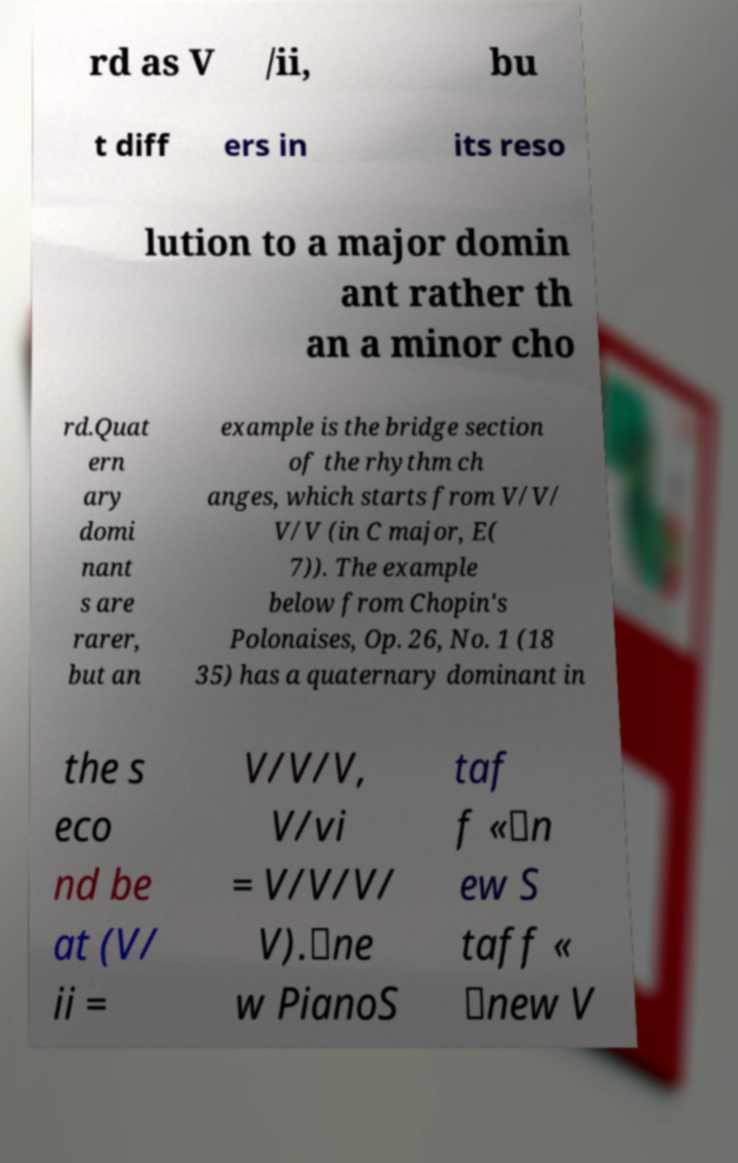Please identify and transcribe the text found in this image. rd as V /ii, bu t diff ers in its reso lution to a major domin ant rather th an a minor cho rd.Quat ern ary domi nant s are rarer, but an example is the bridge section of the rhythm ch anges, which starts from V/V/ V/V (in C major, E( 7)). The example below from Chopin's Polonaises, Op. 26, No. 1 (18 35) has a quaternary dominant in the s eco nd be at (V/ ii = V/V/V, V/vi = V/V/V/ V).\ne w PianoS taf f «\n ew S taff « \new V 